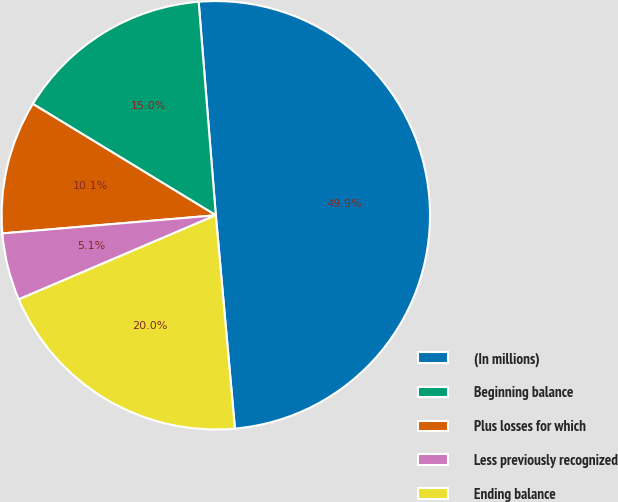Convert chart. <chart><loc_0><loc_0><loc_500><loc_500><pie_chart><fcel>(In millions)<fcel>Beginning balance<fcel>Plus losses for which<fcel>Less previously recognized<fcel>Ending balance<nl><fcel>49.85%<fcel>15.02%<fcel>10.05%<fcel>5.07%<fcel>20.0%<nl></chart> 